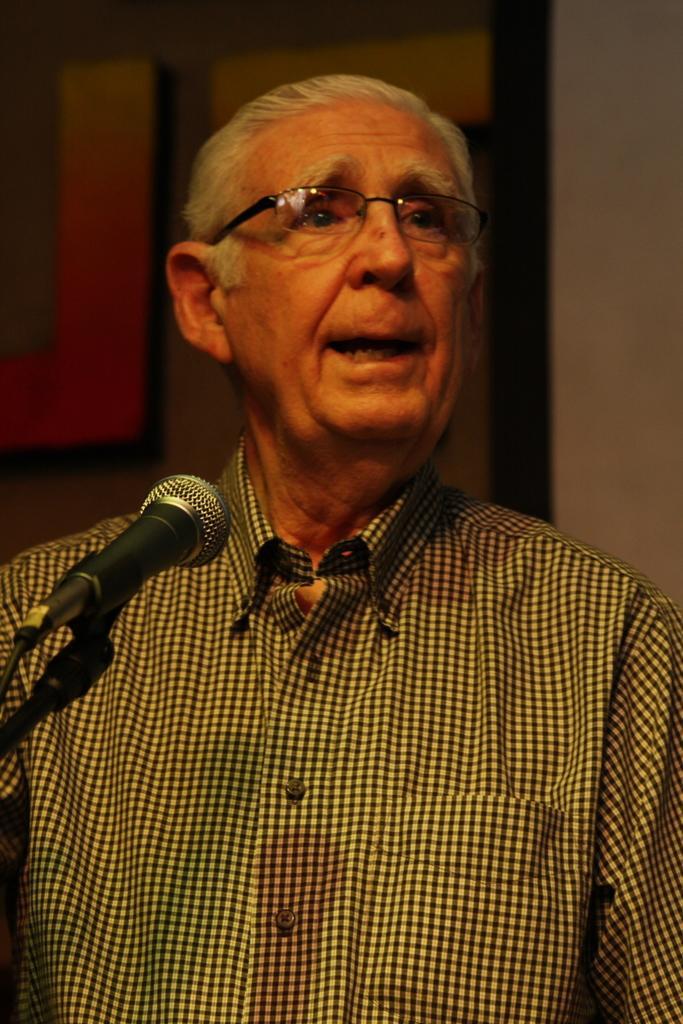Please provide a concise description of this image. In this image there is a man standing. In front of him there is a microphone. Behind him there is a wall. To the left there is text on the wall. 